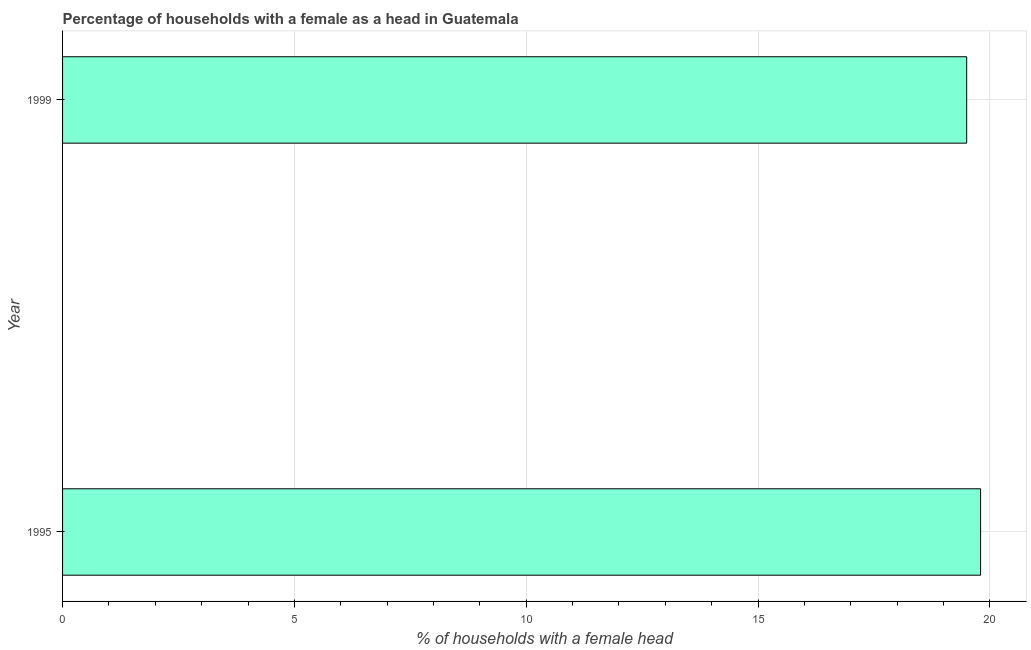Does the graph contain any zero values?
Your response must be concise. No. Does the graph contain grids?
Keep it short and to the point. Yes. What is the title of the graph?
Provide a short and direct response. Percentage of households with a female as a head in Guatemala. What is the label or title of the X-axis?
Provide a short and direct response. % of households with a female head. What is the label or title of the Y-axis?
Your response must be concise. Year. What is the number of female supervised households in 1995?
Provide a short and direct response. 19.8. Across all years, what is the maximum number of female supervised households?
Provide a short and direct response. 19.8. Across all years, what is the minimum number of female supervised households?
Your answer should be compact. 19.5. In which year was the number of female supervised households maximum?
Make the answer very short. 1995. What is the sum of the number of female supervised households?
Provide a short and direct response. 39.3. What is the difference between the number of female supervised households in 1995 and 1999?
Keep it short and to the point. 0.3. What is the average number of female supervised households per year?
Your response must be concise. 19.65. What is the median number of female supervised households?
Your answer should be compact. 19.65. Do a majority of the years between 1999 and 1995 (inclusive) have number of female supervised households greater than 6 %?
Give a very brief answer. No. Is the number of female supervised households in 1995 less than that in 1999?
Provide a succinct answer. No. How many bars are there?
Ensure brevity in your answer.  2. Are all the bars in the graph horizontal?
Provide a short and direct response. Yes. How many years are there in the graph?
Offer a terse response. 2. Are the values on the major ticks of X-axis written in scientific E-notation?
Keep it short and to the point. No. What is the % of households with a female head of 1995?
Offer a terse response. 19.8. 